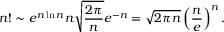Convert formula to latex. <formula><loc_0><loc_0><loc_500><loc_500>n ! \sim e ^ { n \ln n } n { \sqrt { \frac { 2 \pi } { n } } } e ^ { - n } = { \sqrt { 2 \pi n } } \left ( { \frac { n } { e } } \right ) ^ { n } .</formula> 